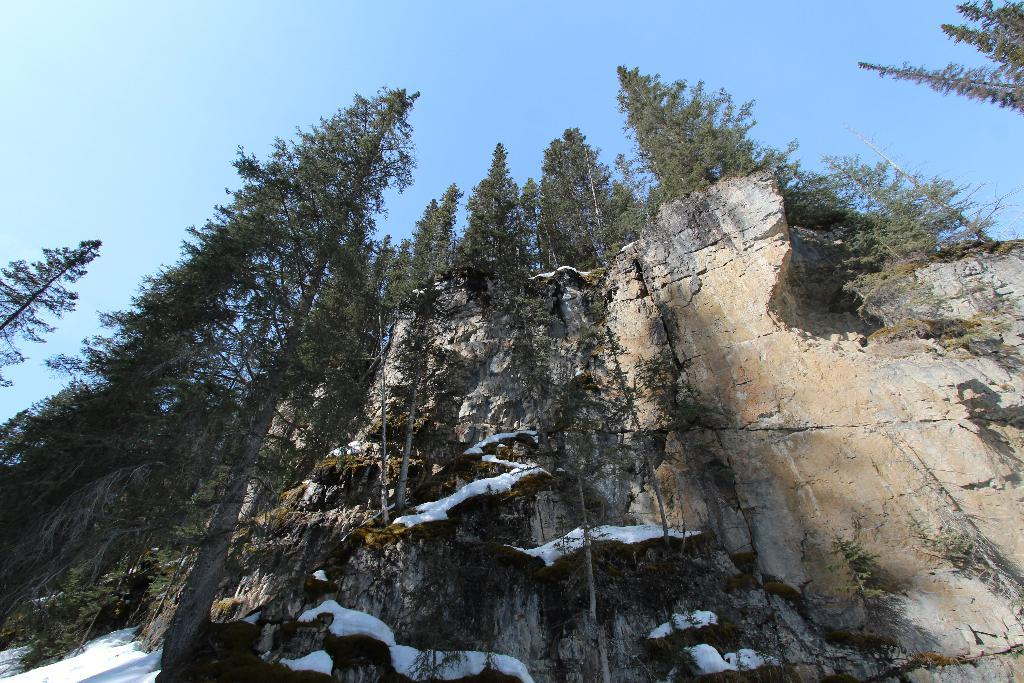What type of vegetation can be seen in the image? There are trees in the image. What is present at the left bottom of the image? There is snow at the left bottom of the image. What is visible at the top of the image? The sky is visible at the top of the image. Can you see a train passing through the snow in the image? There is no train present in the image; it only shows trees, snow, and the sky. Are there any flowers visible in the image? There is no mention of flowers in the provided facts, and they are not visible in the image. 